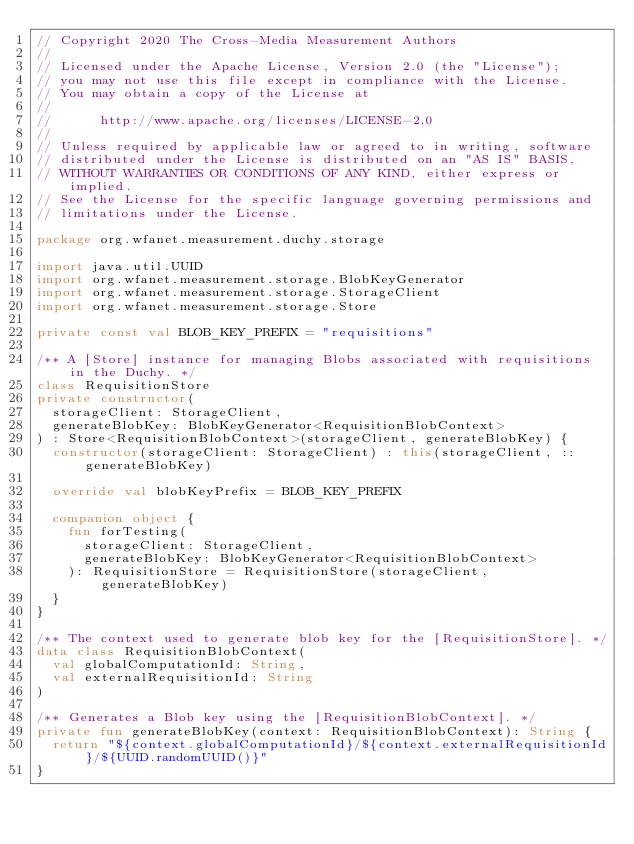<code> <loc_0><loc_0><loc_500><loc_500><_Kotlin_>// Copyright 2020 The Cross-Media Measurement Authors
//
// Licensed under the Apache License, Version 2.0 (the "License");
// you may not use this file except in compliance with the License.
// You may obtain a copy of the License at
//
//      http://www.apache.org/licenses/LICENSE-2.0
//
// Unless required by applicable law or agreed to in writing, software
// distributed under the License is distributed on an "AS IS" BASIS,
// WITHOUT WARRANTIES OR CONDITIONS OF ANY KIND, either express or implied.
// See the License for the specific language governing permissions and
// limitations under the License.

package org.wfanet.measurement.duchy.storage

import java.util.UUID
import org.wfanet.measurement.storage.BlobKeyGenerator
import org.wfanet.measurement.storage.StorageClient
import org.wfanet.measurement.storage.Store

private const val BLOB_KEY_PREFIX = "requisitions"

/** A [Store] instance for managing Blobs associated with requisitions in the Duchy. */
class RequisitionStore
private constructor(
  storageClient: StorageClient,
  generateBlobKey: BlobKeyGenerator<RequisitionBlobContext>
) : Store<RequisitionBlobContext>(storageClient, generateBlobKey) {
  constructor(storageClient: StorageClient) : this(storageClient, ::generateBlobKey)

  override val blobKeyPrefix = BLOB_KEY_PREFIX

  companion object {
    fun forTesting(
      storageClient: StorageClient,
      generateBlobKey: BlobKeyGenerator<RequisitionBlobContext>
    ): RequisitionStore = RequisitionStore(storageClient, generateBlobKey)
  }
}

/** The context used to generate blob key for the [RequisitionStore]. */
data class RequisitionBlobContext(
  val globalComputationId: String,
  val externalRequisitionId: String
)

/** Generates a Blob key using the [RequisitionBlobContext]. */
private fun generateBlobKey(context: RequisitionBlobContext): String {
  return "${context.globalComputationId}/${context.externalRequisitionId}/${UUID.randomUUID()}"
}
</code> 